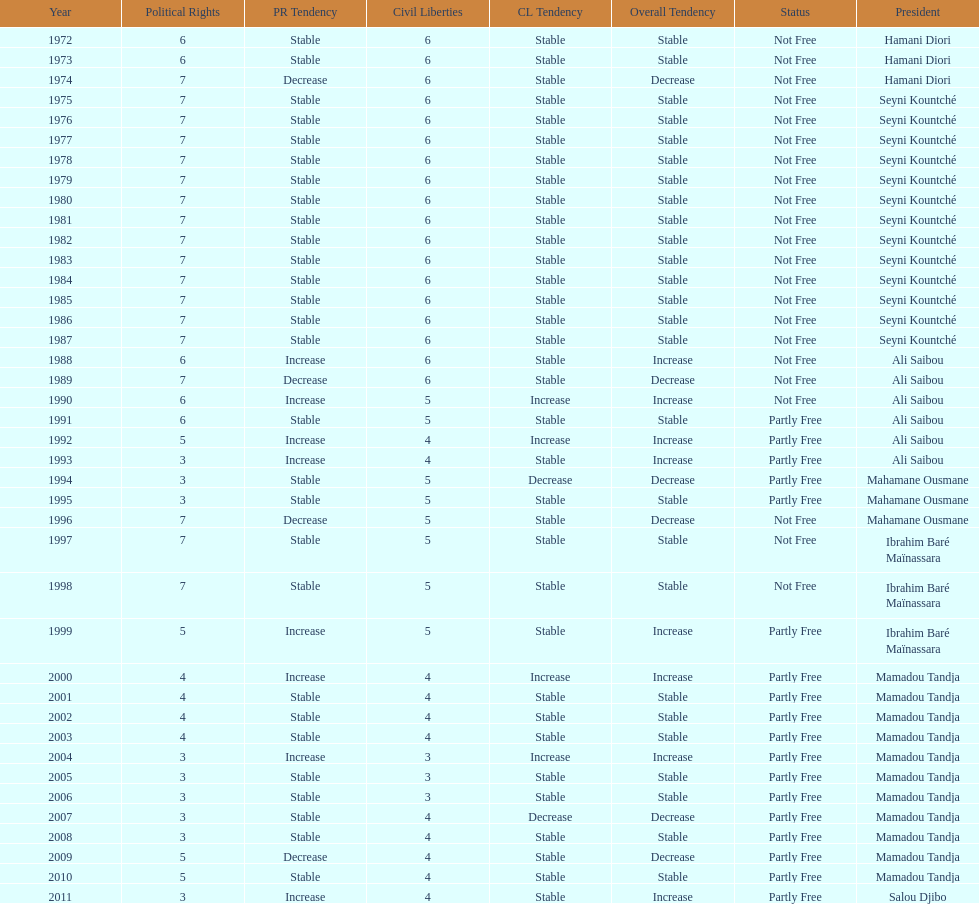Who held the presidential office prior to mamadou tandja? Ibrahim Baré Maïnassara. 